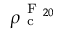<formula> <loc_0><loc_0><loc_500><loc_500>\rho _ { c } ^ { F _ { 2 0 } }</formula> 